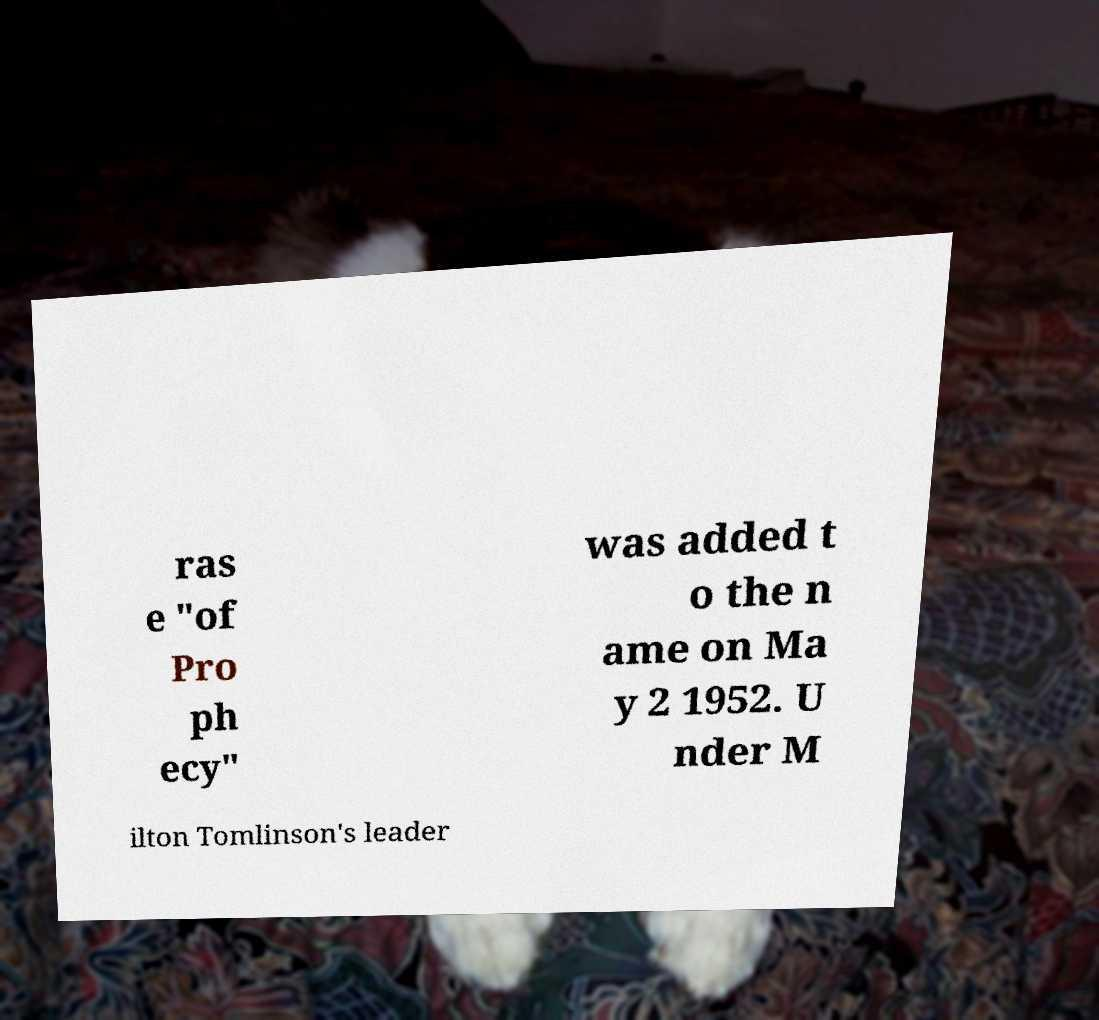Can you accurately transcribe the text from the provided image for me? ras e "of Pro ph ecy" was added t o the n ame on Ma y 2 1952. U nder M ilton Tomlinson's leader 